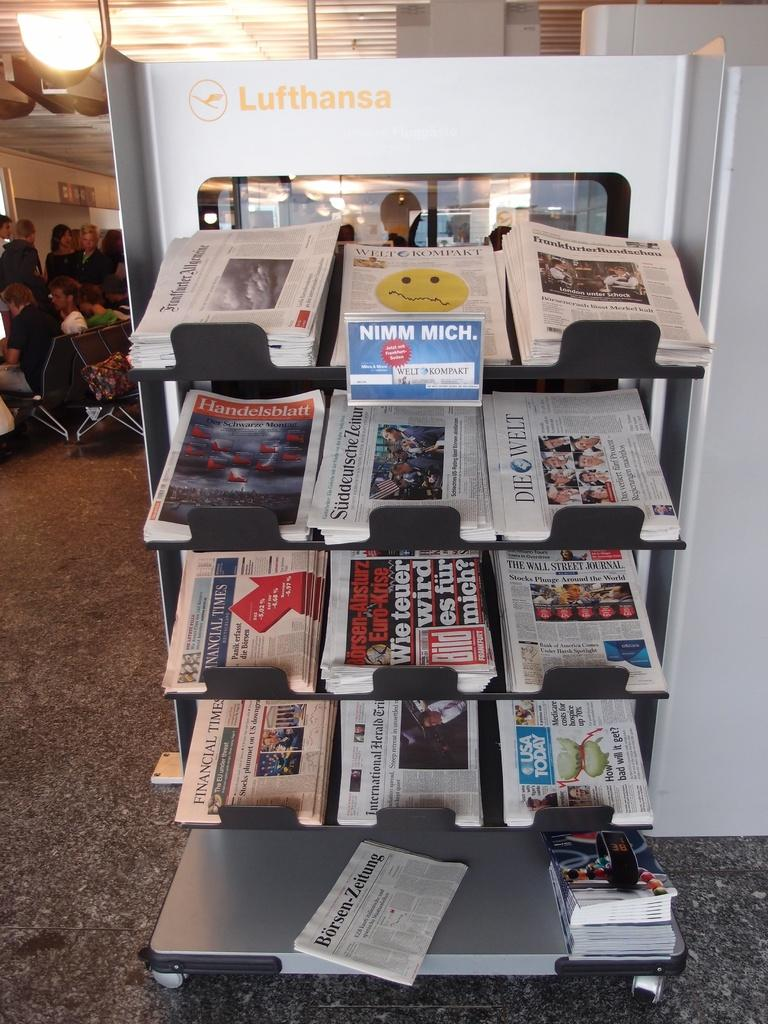<image>
Describe the image concisely. Stack of newspaper with one that is titled "Die Welt". 